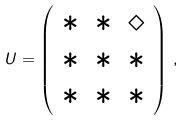Convert formula to latex. <formula><loc_0><loc_0><loc_500><loc_500>U = \left ( \begin{array} { c c c } \ast & \ast & \diamond \\ \ast & \ast & \ast \\ \ast & \ast & \ast \end{array} \right ) \, ,</formula> 